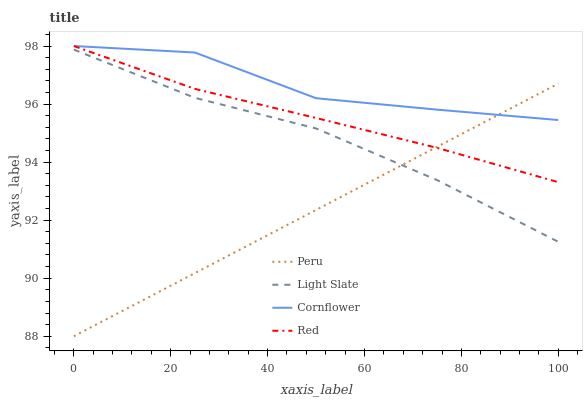Does Peru have the minimum area under the curve?
Answer yes or no. Yes. Does Cornflower have the maximum area under the curve?
Answer yes or no. Yes. Does Red have the minimum area under the curve?
Answer yes or no. No. Does Red have the maximum area under the curve?
Answer yes or no. No. Is Peru the smoothest?
Answer yes or no. Yes. Is Cornflower the roughest?
Answer yes or no. Yes. Is Red the smoothest?
Answer yes or no. No. Is Red the roughest?
Answer yes or no. No. Does Peru have the lowest value?
Answer yes or no. Yes. Does Red have the lowest value?
Answer yes or no. No. Does Red have the highest value?
Answer yes or no. Yes. Does Peru have the highest value?
Answer yes or no. No. Is Light Slate less than Cornflower?
Answer yes or no. Yes. Is Red greater than Light Slate?
Answer yes or no. Yes. Does Red intersect Cornflower?
Answer yes or no. Yes. Is Red less than Cornflower?
Answer yes or no. No. Is Red greater than Cornflower?
Answer yes or no. No. Does Light Slate intersect Cornflower?
Answer yes or no. No. 